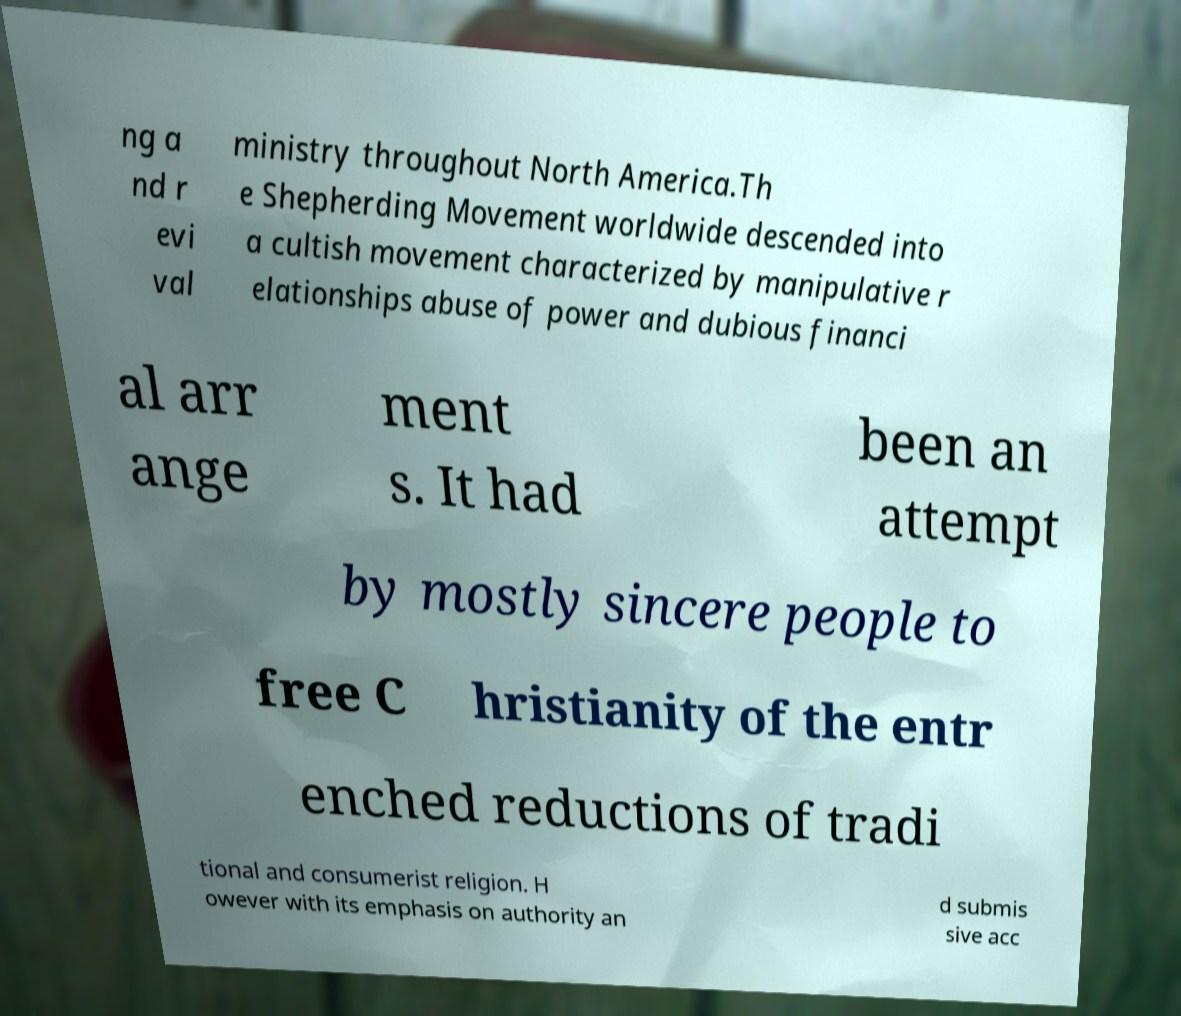Could you extract and type out the text from this image? ng a nd r evi val ministry throughout North America.Th e Shepherding Movement worldwide descended into a cultish movement characterized by manipulative r elationships abuse of power and dubious financi al arr ange ment s. It had been an attempt by mostly sincere people to free C hristianity of the entr enched reductions of tradi tional and consumerist religion. H owever with its emphasis on authority an d submis sive acc 